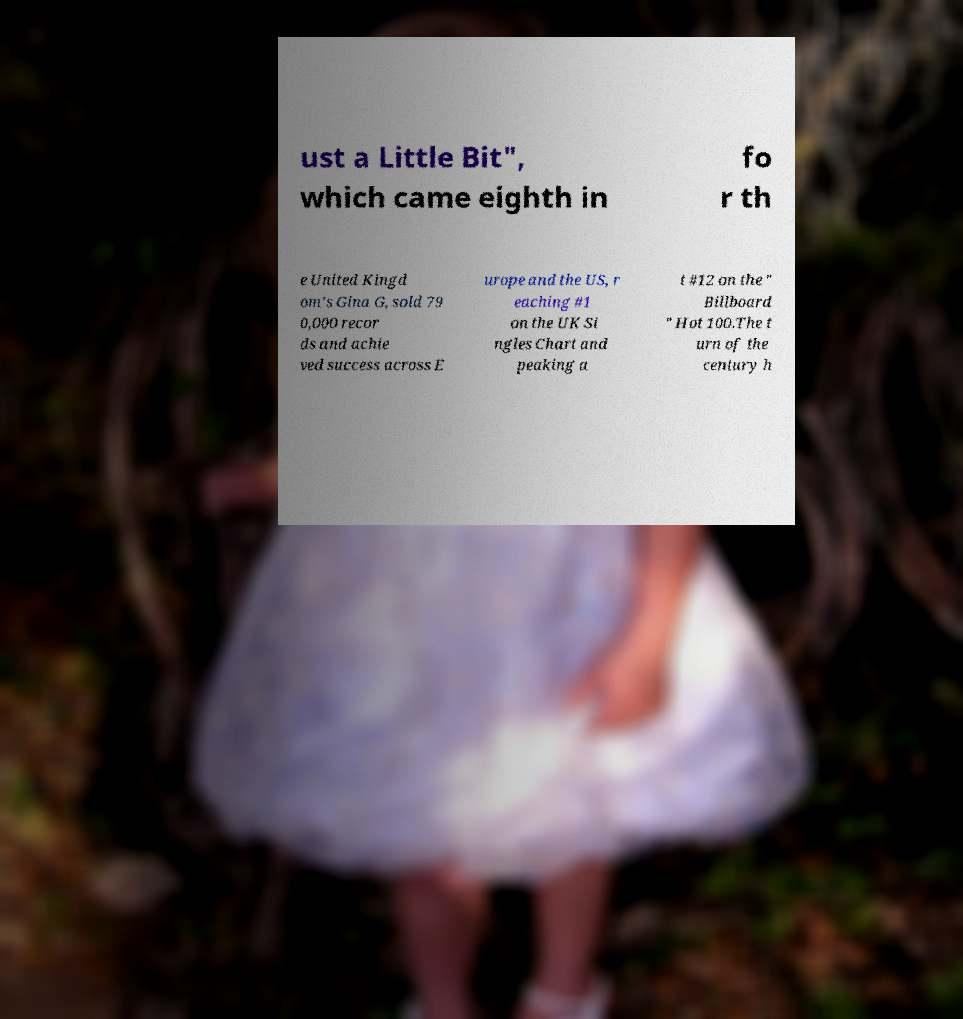There's text embedded in this image that I need extracted. Can you transcribe it verbatim? ust a Little Bit", which came eighth in fo r th e United Kingd om's Gina G, sold 79 0,000 recor ds and achie ved success across E urope and the US, r eaching #1 on the UK Si ngles Chart and peaking a t #12 on the " Billboard " Hot 100.The t urn of the century h 